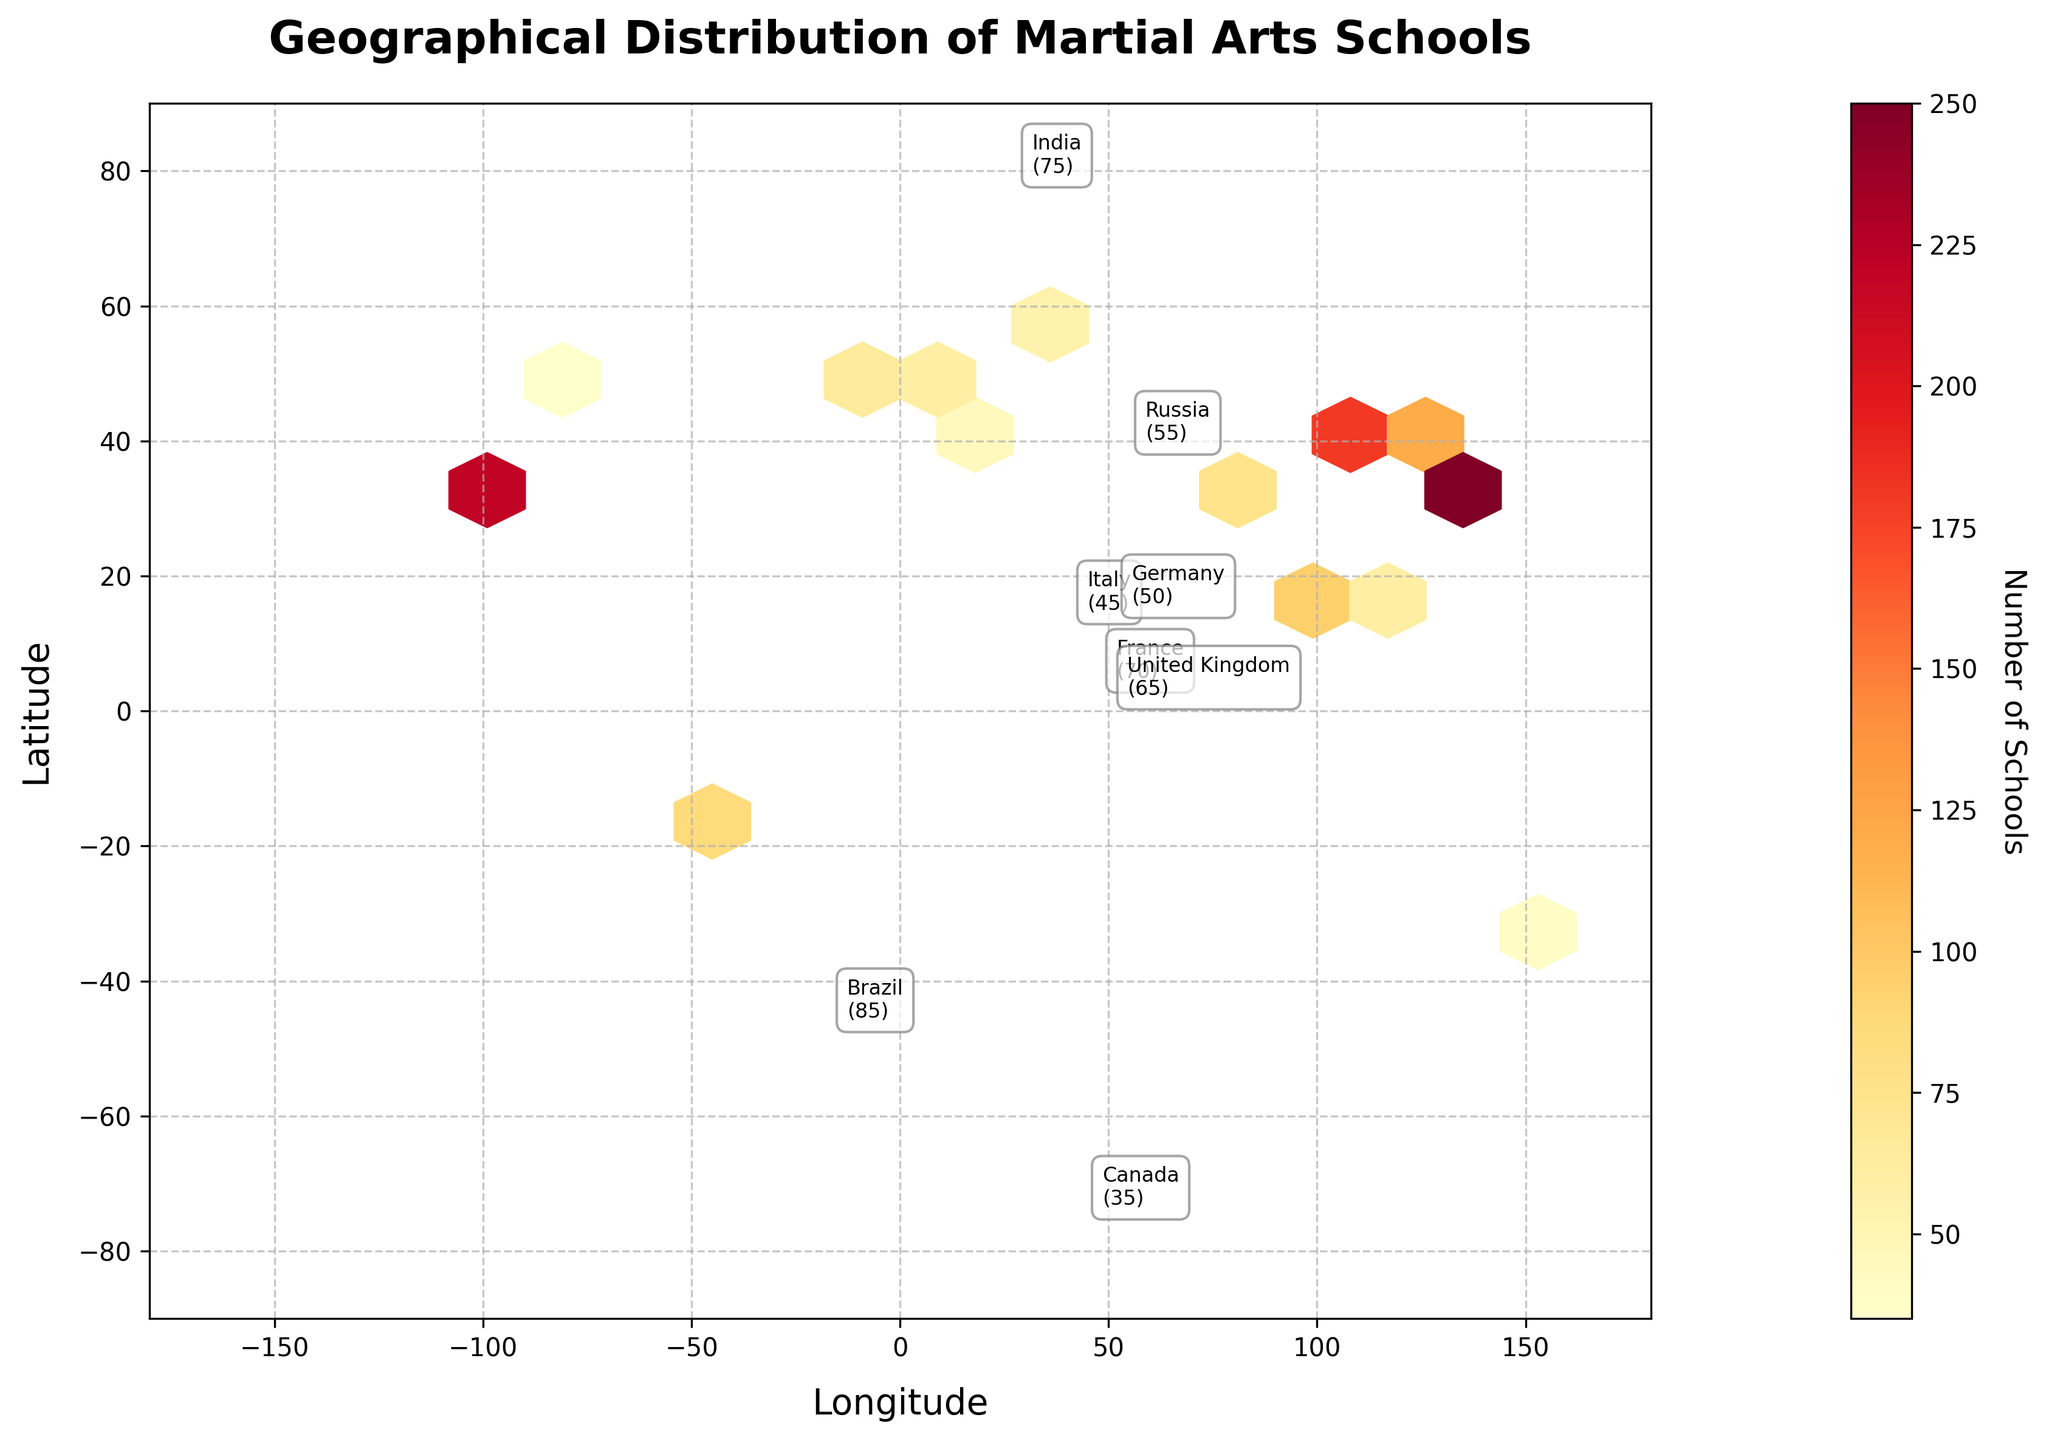What's the title of the figure? The title is displayed at the top of the figure and is usually one of the most visible elements. The title provides a summary of what the figure represents.
Answer: Geographical Distribution of Martial Arts Schools What does the color represent in the hexbin plot? The color represents the number of martial arts schools, which is indicated by the color bar on the right-hand side of the plot. Darker colors indicate higher numbers of schools.
Answer: Number of Schools Which country has the highest number of martial arts schools? Annotations and the color intensity in the hexbin plot help to quickly identify the countries with the highest number of schools. Japan has the highest number, as indicated by the deepest color and the annotation.
Answer: Japan What's the longitude range of the figure? The x-axis represents longitude and spans from -180 to 180. These values are typically labeled along the axis in the plot.
Answer: -180 to 180 How many martial arts schools are there in South Korea and Brazil combined? By adding the number of schools from the annotations for South Korea (120) and Brazil (85), we get the total number of schools in both countries.
Answer: 205 Which countries are labeled in the northern hemisphere? Countries in the northern hemisphere will have positive values for latitude. By checking the positive latitude annotations, we find Japan, China, South Korea, United States, France, United Kingdom, Russia, Germany, and Canada.
Answer: Japan, China, South Korea, United States, France, United Kingdom, Russia, Germany, Canada How does the distribution of schools in Japan compare to the United States? Comparing the number of schools annotated over Japan and the United States: Japan has 250 schools whereas the United States has 220.
Answer: Japan has more schools Which countries have fewer than 50 martial arts schools? Check the annotations in the plot and list countries with schools less than 50. Based on the data: Australia (40), Germany (50), Canada (35), and Italy (45).
Answer: Australia, Canada, Italy What is the general trend of martial arts school distribution in Asia? By observing the hexbin colors and the number of annotations in Asian countries (Japan, China, South Korea, Thailand, Philippines, India), it is seen that there are generally high numbers of martial arts schools in this region.
Answer: High concentration What does the color bar label indicate? The label text on the color bar typically indicates what the color intensity represents in the plot. In this case, it is the number of martial arts schools.
Answer: Number of Schools 